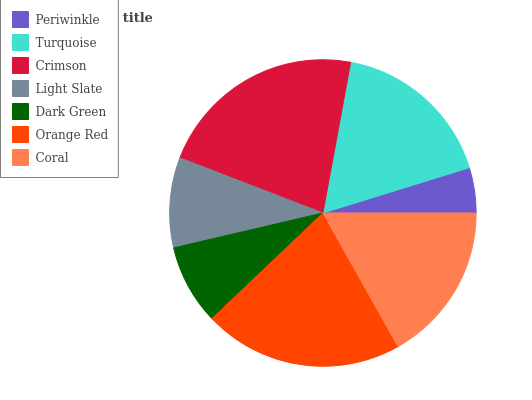Is Periwinkle the minimum?
Answer yes or no. Yes. Is Crimson the maximum?
Answer yes or no. Yes. Is Turquoise the minimum?
Answer yes or no. No. Is Turquoise the maximum?
Answer yes or no. No. Is Turquoise greater than Periwinkle?
Answer yes or no. Yes. Is Periwinkle less than Turquoise?
Answer yes or no. Yes. Is Periwinkle greater than Turquoise?
Answer yes or no. No. Is Turquoise less than Periwinkle?
Answer yes or no. No. Is Coral the high median?
Answer yes or no. Yes. Is Coral the low median?
Answer yes or no. Yes. Is Periwinkle the high median?
Answer yes or no. No. Is Orange Red the low median?
Answer yes or no. No. 